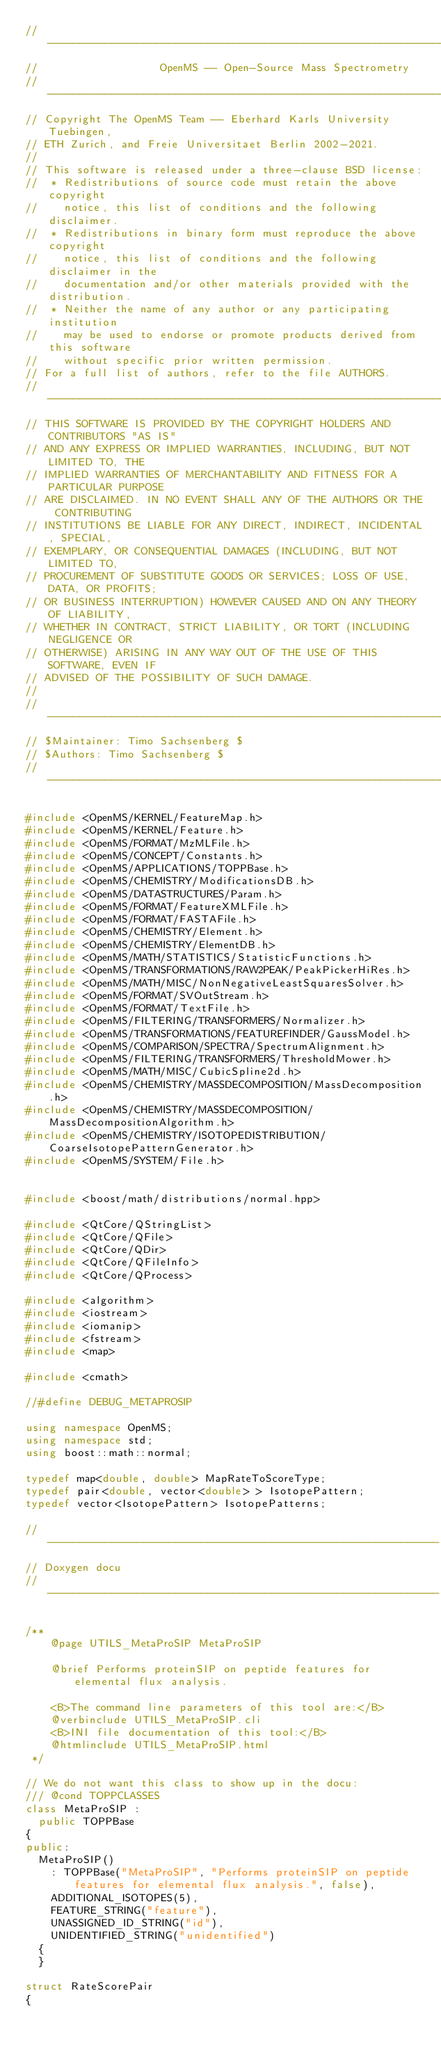<code> <loc_0><loc_0><loc_500><loc_500><_C++_>// --------------------------------------------------------------------------
//                   OpenMS -- Open-Source Mass Spectrometry
// --------------------------------------------------------------------------
// Copyright The OpenMS Team -- Eberhard Karls University Tuebingen,
// ETH Zurich, and Freie Universitaet Berlin 2002-2021.
//
// This software is released under a three-clause BSD license:
//  * Redistributions of source code must retain the above copyright
//    notice, this list of conditions and the following disclaimer.
//  * Redistributions in binary form must reproduce the above copyright
//    notice, this list of conditions and the following disclaimer in the
//    documentation and/or other materials provided with the distribution.
//  * Neither the name of any author or any participating institution
//    may be used to endorse or promote products derived from this software
//    without specific prior written permission.
// For a full list of authors, refer to the file AUTHORS.
// --------------------------------------------------------------------------
// THIS SOFTWARE IS PROVIDED BY THE COPYRIGHT HOLDERS AND CONTRIBUTORS "AS IS"
// AND ANY EXPRESS OR IMPLIED WARRANTIES, INCLUDING, BUT NOT LIMITED TO, THE
// IMPLIED WARRANTIES OF MERCHANTABILITY AND FITNESS FOR A PARTICULAR PURPOSE
// ARE DISCLAIMED. IN NO EVENT SHALL ANY OF THE AUTHORS OR THE CONTRIBUTING
// INSTITUTIONS BE LIABLE FOR ANY DIRECT, INDIRECT, INCIDENTAL, SPECIAL,
// EXEMPLARY, OR CONSEQUENTIAL DAMAGES (INCLUDING, BUT NOT LIMITED TO,
// PROCUREMENT OF SUBSTITUTE GOODS OR SERVICES; LOSS OF USE, DATA, OR PROFITS;
// OR BUSINESS INTERRUPTION) HOWEVER CAUSED AND ON ANY THEORY OF LIABILITY,
// WHETHER IN CONTRACT, STRICT LIABILITY, OR TORT (INCLUDING NEGLIGENCE OR
// OTHERWISE) ARISING IN ANY WAY OUT OF THE USE OF THIS SOFTWARE, EVEN IF
// ADVISED OF THE POSSIBILITY OF SUCH DAMAGE.
//
// --------------------------------------------------------------------------
// $Maintainer: Timo Sachsenberg $
// $Authors: Timo Sachsenberg $
// --------------------------------------------------------------------------

#include <OpenMS/KERNEL/FeatureMap.h>
#include <OpenMS/KERNEL/Feature.h>
#include <OpenMS/FORMAT/MzMLFile.h>
#include <OpenMS/CONCEPT/Constants.h>
#include <OpenMS/APPLICATIONS/TOPPBase.h>
#include <OpenMS/CHEMISTRY/ModificationsDB.h>
#include <OpenMS/DATASTRUCTURES/Param.h>
#include <OpenMS/FORMAT/FeatureXMLFile.h>
#include <OpenMS/FORMAT/FASTAFile.h>
#include <OpenMS/CHEMISTRY/Element.h>
#include <OpenMS/CHEMISTRY/ElementDB.h>
#include <OpenMS/MATH/STATISTICS/StatisticFunctions.h>
#include <OpenMS/TRANSFORMATIONS/RAW2PEAK/PeakPickerHiRes.h>
#include <OpenMS/MATH/MISC/NonNegativeLeastSquaresSolver.h>
#include <OpenMS/FORMAT/SVOutStream.h>
#include <OpenMS/FORMAT/TextFile.h>
#include <OpenMS/FILTERING/TRANSFORMERS/Normalizer.h>
#include <OpenMS/TRANSFORMATIONS/FEATUREFINDER/GaussModel.h>
#include <OpenMS/COMPARISON/SPECTRA/SpectrumAlignment.h>
#include <OpenMS/FILTERING/TRANSFORMERS/ThresholdMower.h>
#include <OpenMS/MATH/MISC/CubicSpline2d.h>
#include <OpenMS/CHEMISTRY/MASSDECOMPOSITION/MassDecomposition.h>
#include <OpenMS/CHEMISTRY/MASSDECOMPOSITION/MassDecompositionAlgorithm.h>
#include <OpenMS/CHEMISTRY/ISOTOPEDISTRIBUTION/CoarseIsotopePatternGenerator.h>
#include <OpenMS/SYSTEM/File.h>


#include <boost/math/distributions/normal.hpp>

#include <QtCore/QStringList>
#include <QtCore/QFile>
#include <QtCore/QDir>
#include <QtCore/QFileInfo>
#include <QtCore/QProcess>

#include <algorithm>
#include <iostream>
#include <iomanip>
#include <fstream>
#include <map>

#include <cmath>

//#define DEBUG_METAPROSIP

using namespace OpenMS;
using namespace std;
using boost::math::normal;

typedef map<double, double> MapRateToScoreType;
typedef pair<double, vector<double> > IsotopePattern;
typedef vector<IsotopePattern> IsotopePatterns;

//-------------------------------------------------------------
// Doxygen docu
//-------------------------------------------------------------

/**
    @page UTILS_MetaProSIP MetaProSIP

    @brief Performs proteinSIP on peptide features for elemental flux analysis.

    <B>The command line parameters of this tool are:</B>
    @verbinclude UTILS_MetaProSIP.cli
    <B>INI file documentation of this tool:</B>
    @htmlinclude UTILS_MetaProSIP.html
 */

// We do not want this class to show up in the docu:
/// @cond TOPPCLASSES
class MetaProSIP :
  public TOPPBase
{
public:
  MetaProSIP()
    : TOPPBase("MetaProSIP", "Performs proteinSIP on peptide features for elemental flux analysis.", false),
    ADDITIONAL_ISOTOPES(5),
    FEATURE_STRING("feature"),
    UNASSIGNED_ID_STRING("id"),
    UNIDENTIFIED_STRING("unidentified")
  {
  }

struct RateScorePair
{</code> 